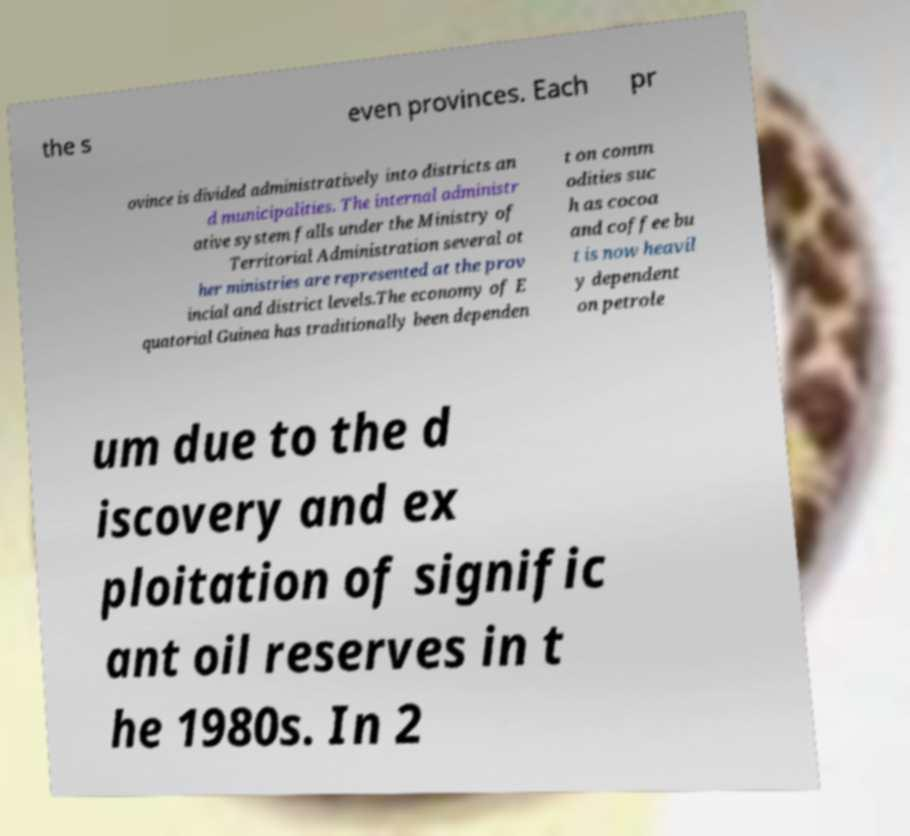Can you read and provide the text displayed in the image?This photo seems to have some interesting text. Can you extract and type it out for me? the s even provinces. Each pr ovince is divided administratively into districts an d municipalities. The internal administr ative system falls under the Ministry of Territorial Administration several ot her ministries are represented at the prov incial and district levels.The economy of E quatorial Guinea has traditionally been dependen t on comm odities suc h as cocoa and coffee bu t is now heavil y dependent on petrole um due to the d iscovery and ex ploitation of signific ant oil reserves in t he 1980s. In 2 